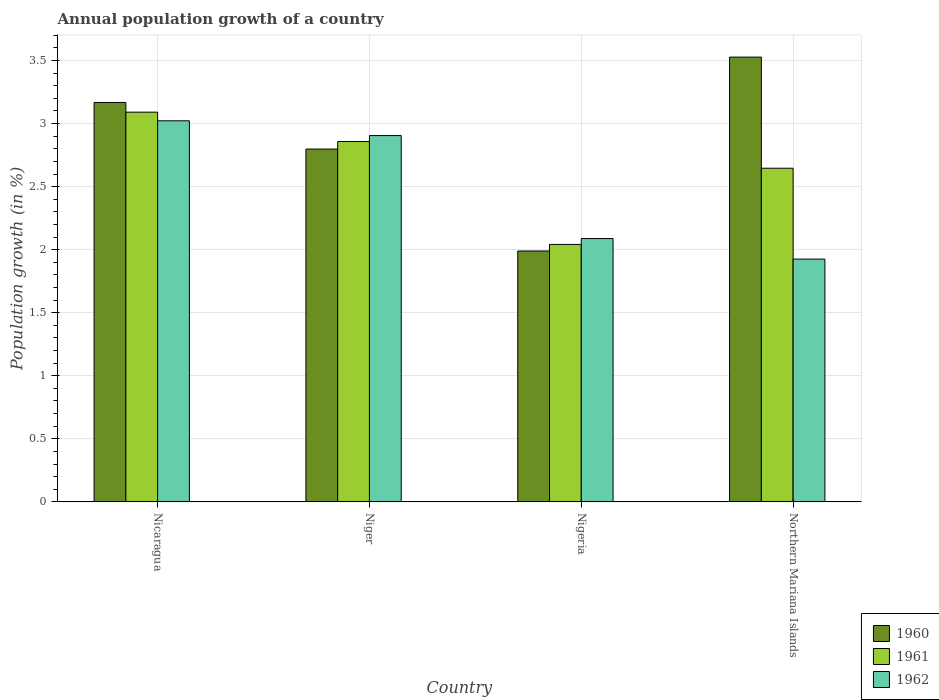How many different coloured bars are there?
Your response must be concise. 3. How many groups of bars are there?
Offer a terse response. 4. Are the number of bars per tick equal to the number of legend labels?
Provide a succinct answer. Yes. Are the number of bars on each tick of the X-axis equal?
Provide a short and direct response. Yes. How many bars are there on the 1st tick from the left?
Make the answer very short. 3. How many bars are there on the 4th tick from the right?
Offer a terse response. 3. What is the label of the 1st group of bars from the left?
Make the answer very short. Nicaragua. In how many cases, is the number of bars for a given country not equal to the number of legend labels?
Give a very brief answer. 0. What is the annual population growth in 1962 in Nigeria?
Provide a short and direct response. 2.09. Across all countries, what is the maximum annual population growth in 1960?
Ensure brevity in your answer.  3.53. Across all countries, what is the minimum annual population growth in 1960?
Give a very brief answer. 1.99. In which country was the annual population growth in 1960 maximum?
Keep it short and to the point. Northern Mariana Islands. In which country was the annual population growth in 1961 minimum?
Your answer should be very brief. Nigeria. What is the total annual population growth in 1960 in the graph?
Provide a short and direct response. 11.48. What is the difference between the annual population growth in 1960 in Nicaragua and that in Nigeria?
Ensure brevity in your answer.  1.18. What is the difference between the annual population growth in 1962 in Nicaragua and the annual population growth in 1960 in Northern Mariana Islands?
Offer a very short reply. -0.51. What is the average annual population growth in 1962 per country?
Keep it short and to the point. 2.49. What is the difference between the annual population growth of/in 1962 and annual population growth of/in 1961 in Nigeria?
Ensure brevity in your answer.  0.05. What is the ratio of the annual population growth in 1961 in Nicaragua to that in Northern Mariana Islands?
Provide a short and direct response. 1.17. Is the annual population growth in 1962 in Nicaragua less than that in Niger?
Your response must be concise. No. Is the difference between the annual population growth in 1962 in Nicaragua and Nigeria greater than the difference between the annual population growth in 1961 in Nicaragua and Nigeria?
Ensure brevity in your answer.  No. What is the difference between the highest and the second highest annual population growth in 1962?
Give a very brief answer. -0.12. What is the difference between the highest and the lowest annual population growth in 1961?
Your answer should be compact. 1.05. In how many countries, is the annual population growth in 1961 greater than the average annual population growth in 1961 taken over all countries?
Ensure brevity in your answer.  2. Is the sum of the annual population growth in 1961 in Nigeria and Northern Mariana Islands greater than the maximum annual population growth in 1960 across all countries?
Offer a terse response. Yes. What does the 2nd bar from the left in Niger represents?
Ensure brevity in your answer.  1961. What does the 3rd bar from the right in Northern Mariana Islands represents?
Give a very brief answer. 1960. Is it the case that in every country, the sum of the annual population growth in 1962 and annual population growth in 1961 is greater than the annual population growth in 1960?
Ensure brevity in your answer.  Yes. Are the values on the major ticks of Y-axis written in scientific E-notation?
Your answer should be compact. No. Does the graph contain any zero values?
Offer a terse response. No. How many legend labels are there?
Your answer should be very brief. 3. What is the title of the graph?
Your answer should be very brief. Annual population growth of a country. Does "1987" appear as one of the legend labels in the graph?
Provide a succinct answer. No. What is the label or title of the X-axis?
Your answer should be very brief. Country. What is the label or title of the Y-axis?
Your response must be concise. Population growth (in %). What is the Population growth (in %) of 1960 in Nicaragua?
Give a very brief answer. 3.17. What is the Population growth (in %) in 1961 in Nicaragua?
Keep it short and to the point. 3.09. What is the Population growth (in %) of 1962 in Nicaragua?
Keep it short and to the point. 3.02. What is the Population growth (in %) in 1960 in Niger?
Ensure brevity in your answer.  2.8. What is the Population growth (in %) in 1961 in Niger?
Offer a very short reply. 2.86. What is the Population growth (in %) of 1962 in Niger?
Your answer should be very brief. 2.9. What is the Population growth (in %) in 1960 in Nigeria?
Ensure brevity in your answer.  1.99. What is the Population growth (in %) of 1961 in Nigeria?
Your answer should be compact. 2.04. What is the Population growth (in %) of 1962 in Nigeria?
Offer a terse response. 2.09. What is the Population growth (in %) in 1960 in Northern Mariana Islands?
Keep it short and to the point. 3.53. What is the Population growth (in %) in 1961 in Northern Mariana Islands?
Make the answer very short. 2.65. What is the Population growth (in %) in 1962 in Northern Mariana Islands?
Your answer should be compact. 1.93. Across all countries, what is the maximum Population growth (in %) of 1960?
Offer a terse response. 3.53. Across all countries, what is the maximum Population growth (in %) of 1961?
Give a very brief answer. 3.09. Across all countries, what is the maximum Population growth (in %) in 1962?
Offer a very short reply. 3.02. Across all countries, what is the minimum Population growth (in %) of 1960?
Ensure brevity in your answer.  1.99. Across all countries, what is the minimum Population growth (in %) in 1961?
Keep it short and to the point. 2.04. Across all countries, what is the minimum Population growth (in %) in 1962?
Your answer should be very brief. 1.93. What is the total Population growth (in %) of 1960 in the graph?
Your answer should be compact. 11.48. What is the total Population growth (in %) in 1961 in the graph?
Keep it short and to the point. 10.64. What is the total Population growth (in %) in 1962 in the graph?
Your answer should be compact. 9.94. What is the difference between the Population growth (in %) in 1960 in Nicaragua and that in Niger?
Offer a terse response. 0.37. What is the difference between the Population growth (in %) of 1961 in Nicaragua and that in Niger?
Give a very brief answer. 0.23. What is the difference between the Population growth (in %) in 1962 in Nicaragua and that in Niger?
Your answer should be very brief. 0.12. What is the difference between the Population growth (in %) in 1960 in Nicaragua and that in Nigeria?
Give a very brief answer. 1.18. What is the difference between the Population growth (in %) of 1961 in Nicaragua and that in Nigeria?
Offer a very short reply. 1.05. What is the difference between the Population growth (in %) in 1962 in Nicaragua and that in Nigeria?
Provide a short and direct response. 0.93. What is the difference between the Population growth (in %) in 1960 in Nicaragua and that in Northern Mariana Islands?
Offer a very short reply. -0.36. What is the difference between the Population growth (in %) of 1961 in Nicaragua and that in Northern Mariana Islands?
Your answer should be very brief. 0.44. What is the difference between the Population growth (in %) of 1962 in Nicaragua and that in Northern Mariana Islands?
Offer a very short reply. 1.1. What is the difference between the Population growth (in %) in 1960 in Niger and that in Nigeria?
Make the answer very short. 0.81. What is the difference between the Population growth (in %) in 1961 in Niger and that in Nigeria?
Keep it short and to the point. 0.82. What is the difference between the Population growth (in %) in 1962 in Niger and that in Nigeria?
Give a very brief answer. 0.82. What is the difference between the Population growth (in %) in 1960 in Niger and that in Northern Mariana Islands?
Offer a very short reply. -0.73. What is the difference between the Population growth (in %) of 1961 in Niger and that in Northern Mariana Islands?
Keep it short and to the point. 0.21. What is the difference between the Population growth (in %) of 1962 in Niger and that in Northern Mariana Islands?
Your answer should be compact. 0.98. What is the difference between the Population growth (in %) of 1960 in Nigeria and that in Northern Mariana Islands?
Make the answer very short. -1.54. What is the difference between the Population growth (in %) of 1961 in Nigeria and that in Northern Mariana Islands?
Your answer should be very brief. -0.6. What is the difference between the Population growth (in %) of 1962 in Nigeria and that in Northern Mariana Islands?
Give a very brief answer. 0.16. What is the difference between the Population growth (in %) of 1960 in Nicaragua and the Population growth (in %) of 1961 in Niger?
Offer a terse response. 0.31. What is the difference between the Population growth (in %) in 1960 in Nicaragua and the Population growth (in %) in 1962 in Niger?
Offer a terse response. 0.26. What is the difference between the Population growth (in %) of 1961 in Nicaragua and the Population growth (in %) of 1962 in Niger?
Provide a succinct answer. 0.19. What is the difference between the Population growth (in %) in 1960 in Nicaragua and the Population growth (in %) in 1961 in Nigeria?
Offer a very short reply. 1.13. What is the difference between the Population growth (in %) of 1960 in Nicaragua and the Population growth (in %) of 1962 in Nigeria?
Give a very brief answer. 1.08. What is the difference between the Population growth (in %) of 1960 in Nicaragua and the Population growth (in %) of 1961 in Northern Mariana Islands?
Offer a terse response. 0.52. What is the difference between the Population growth (in %) of 1960 in Nicaragua and the Population growth (in %) of 1962 in Northern Mariana Islands?
Make the answer very short. 1.24. What is the difference between the Population growth (in %) in 1961 in Nicaragua and the Population growth (in %) in 1962 in Northern Mariana Islands?
Give a very brief answer. 1.17. What is the difference between the Population growth (in %) of 1960 in Niger and the Population growth (in %) of 1961 in Nigeria?
Provide a succinct answer. 0.76. What is the difference between the Population growth (in %) in 1960 in Niger and the Population growth (in %) in 1962 in Nigeria?
Keep it short and to the point. 0.71. What is the difference between the Population growth (in %) of 1961 in Niger and the Population growth (in %) of 1962 in Nigeria?
Ensure brevity in your answer.  0.77. What is the difference between the Population growth (in %) in 1960 in Niger and the Population growth (in %) in 1961 in Northern Mariana Islands?
Keep it short and to the point. 0.15. What is the difference between the Population growth (in %) of 1960 in Niger and the Population growth (in %) of 1962 in Northern Mariana Islands?
Keep it short and to the point. 0.87. What is the difference between the Population growth (in %) of 1961 in Niger and the Population growth (in %) of 1962 in Northern Mariana Islands?
Give a very brief answer. 0.93. What is the difference between the Population growth (in %) in 1960 in Nigeria and the Population growth (in %) in 1961 in Northern Mariana Islands?
Ensure brevity in your answer.  -0.66. What is the difference between the Population growth (in %) in 1960 in Nigeria and the Population growth (in %) in 1962 in Northern Mariana Islands?
Give a very brief answer. 0.06. What is the difference between the Population growth (in %) in 1961 in Nigeria and the Population growth (in %) in 1962 in Northern Mariana Islands?
Your answer should be compact. 0.12. What is the average Population growth (in %) in 1960 per country?
Offer a very short reply. 2.87. What is the average Population growth (in %) of 1961 per country?
Your response must be concise. 2.66. What is the average Population growth (in %) in 1962 per country?
Your response must be concise. 2.49. What is the difference between the Population growth (in %) in 1960 and Population growth (in %) in 1961 in Nicaragua?
Provide a succinct answer. 0.08. What is the difference between the Population growth (in %) in 1960 and Population growth (in %) in 1962 in Nicaragua?
Your answer should be compact. 0.15. What is the difference between the Population growth (in %) in 1961 and Population growth (in %) in 1962 in Nicaragua?
Make the answer very short. 0.07. What is the difference between the Population growth (in %) of 1960 and Population growth (in %) of 1961 in Niger?
Provide a short and direct response. -0.06. What is the difference between the Population growth (in %) of 1960 and Population growth (in %) of 1962 in Niger?
Keep it short and to the point. -0.11. What is the difference between the Population growth (in %) of 1961 and Population growth (in %) of 1962 in Niger?
Make the answer very short. -0.05. What is the difference between the Population growth (in %) in 1960 and Population growth (in %) in 1961 in Nigeria?
Your response must be concise. -0.05. What is the difference between the Population growth (in %) in 1960 and Population growth (in %) in 1962 in Nigeria?
Keep it short and to the point. -0.1. What is the difference between the Population growth (in %) in 1961 and Population growth (in %) in 1962 in Nigeria?
Offer a very short reply. -0.05. What is the difference between the Population growth (in %) in 1960 and Population growth (in %) in 1961 in Northern Mariana Islands?
Provide a succinct answer. 0.88. What is the difference between the Population growth (in %) in 1960 and Population growth (in %) in 1962 in Northern Mariana Islands?
Your answer should be compact. 1.6. What is the difference between the Population growth (in %) in 1961 and Population growth (in %) in 1962 in Northern Mariana Islands?
Keep it short and to the point. 0.72. What is the ratio of the Population growth (in %) of 1960 in Nicaragua to that in Niger?
Offer a terse response. 1.13. What is the ratio of the Population growth (in %) of 1961 in Nicaragua to that in Niger?
Provide a short and direct response. 1.08. What is the ratio of the Population growth (in %) in 1962 in Nicaragua to that in Niger?
Keep it short and to the point. 1.04. What is the ratio of the Population growth (in %) in 1960 in Nicaragua to that in Nigeria?
Offer a terse response. 1.59. What is the ratio of the Population growth (in %) of 1961 in Nicaragua to that in Nigeria?
Ensure brevity in your answer.  1.51. What is the ratio of the Population growth (in %) in 1962 in Nicaragua to that in Nigeria?
Keep it short and to the point. 1.45. What is the ratio of the Population growth (in %) of 1960 in Nicaragua to that in Northern Mariana Islands?
Make the answer very short. 0.9. What is the ratio of the Population growth (in %) of 1961 in Nicaragua to that in Northern Mariana Islands?
Offer a terse response. 1.17. What is the ratio of the Population growth (in %) of 1962 in Nicaragua to that in Northern Mariana Islands?
Provide a succinct answer. 1.57. What is the ratio of the Population growth (in %) in 1960 in Niger to that in Nigeria?
Offer a very short reply. 1.41. What is the ratio of the Population growth (in %) of 1961 in Niger to that in Nigeria?
Your response must be concise. 1.4. What is the ratio of the Population growth (in %) of 1962 in Niger to that in Nigeria?
Your answer should be compact. 1.39. What is the ratio of the Population growth (in %) in 1960 in Niger to that in Northern Mariana Islands?
Your answer should be compact. 0.79. What is the ratio of the Population growth (in %) of 1961 in Niger to that in Northern Mariana Islands?
Your response must be concise. 1.08. What is the ratio of the Population growth (in %) of 1962 in Niger to that in Northern Mariana Islands?
Your answer should be very brief. 1.51. What is the ratio of the Population growth (in %) of 1960 in Nigeria to that in Northern Mariana Islands?
Your answer should be compact. 0.56. What is the ratio of the Population growth (in %) of 1961 in Nigeria to that in Northern Mariana Islands?
Offer a very short reply. 0.77. What is the ratio of the Population growth (in %) in 1962 in Nigeria to that in Northern Mariana Islands?
Make the answer very short. 1.08. What is the difference between the highest and the second highest Population growth (in %) in 1960?
Keep it short and to the point. 0.36. What is the difference between the highest and the second highest Population growth (in %) in 1961?
Your answer should be very brief. 0.23. What is the difference between the highest and the second highest Population growth (in %) of 1962?
Provide a succinct answer. 0.12. What is the difference between the highest and the lowest Population growth (in %) of 1960?
Provide a short and direct response. 1.54. What is the difference between the highest and the lowest Population growth (in %) in 1961?
Make the answer very short. 1.05. What is the difference between the highest and the lowest Population growth (in %) in 1962?
Provide a succinct answer. 1.1. 